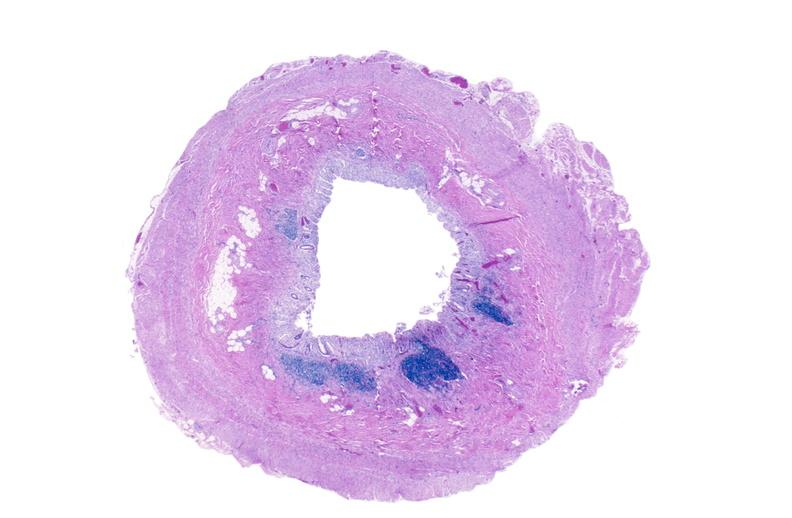s gastrointestinal present?
Answer the question using a single word or phrase. Yes 